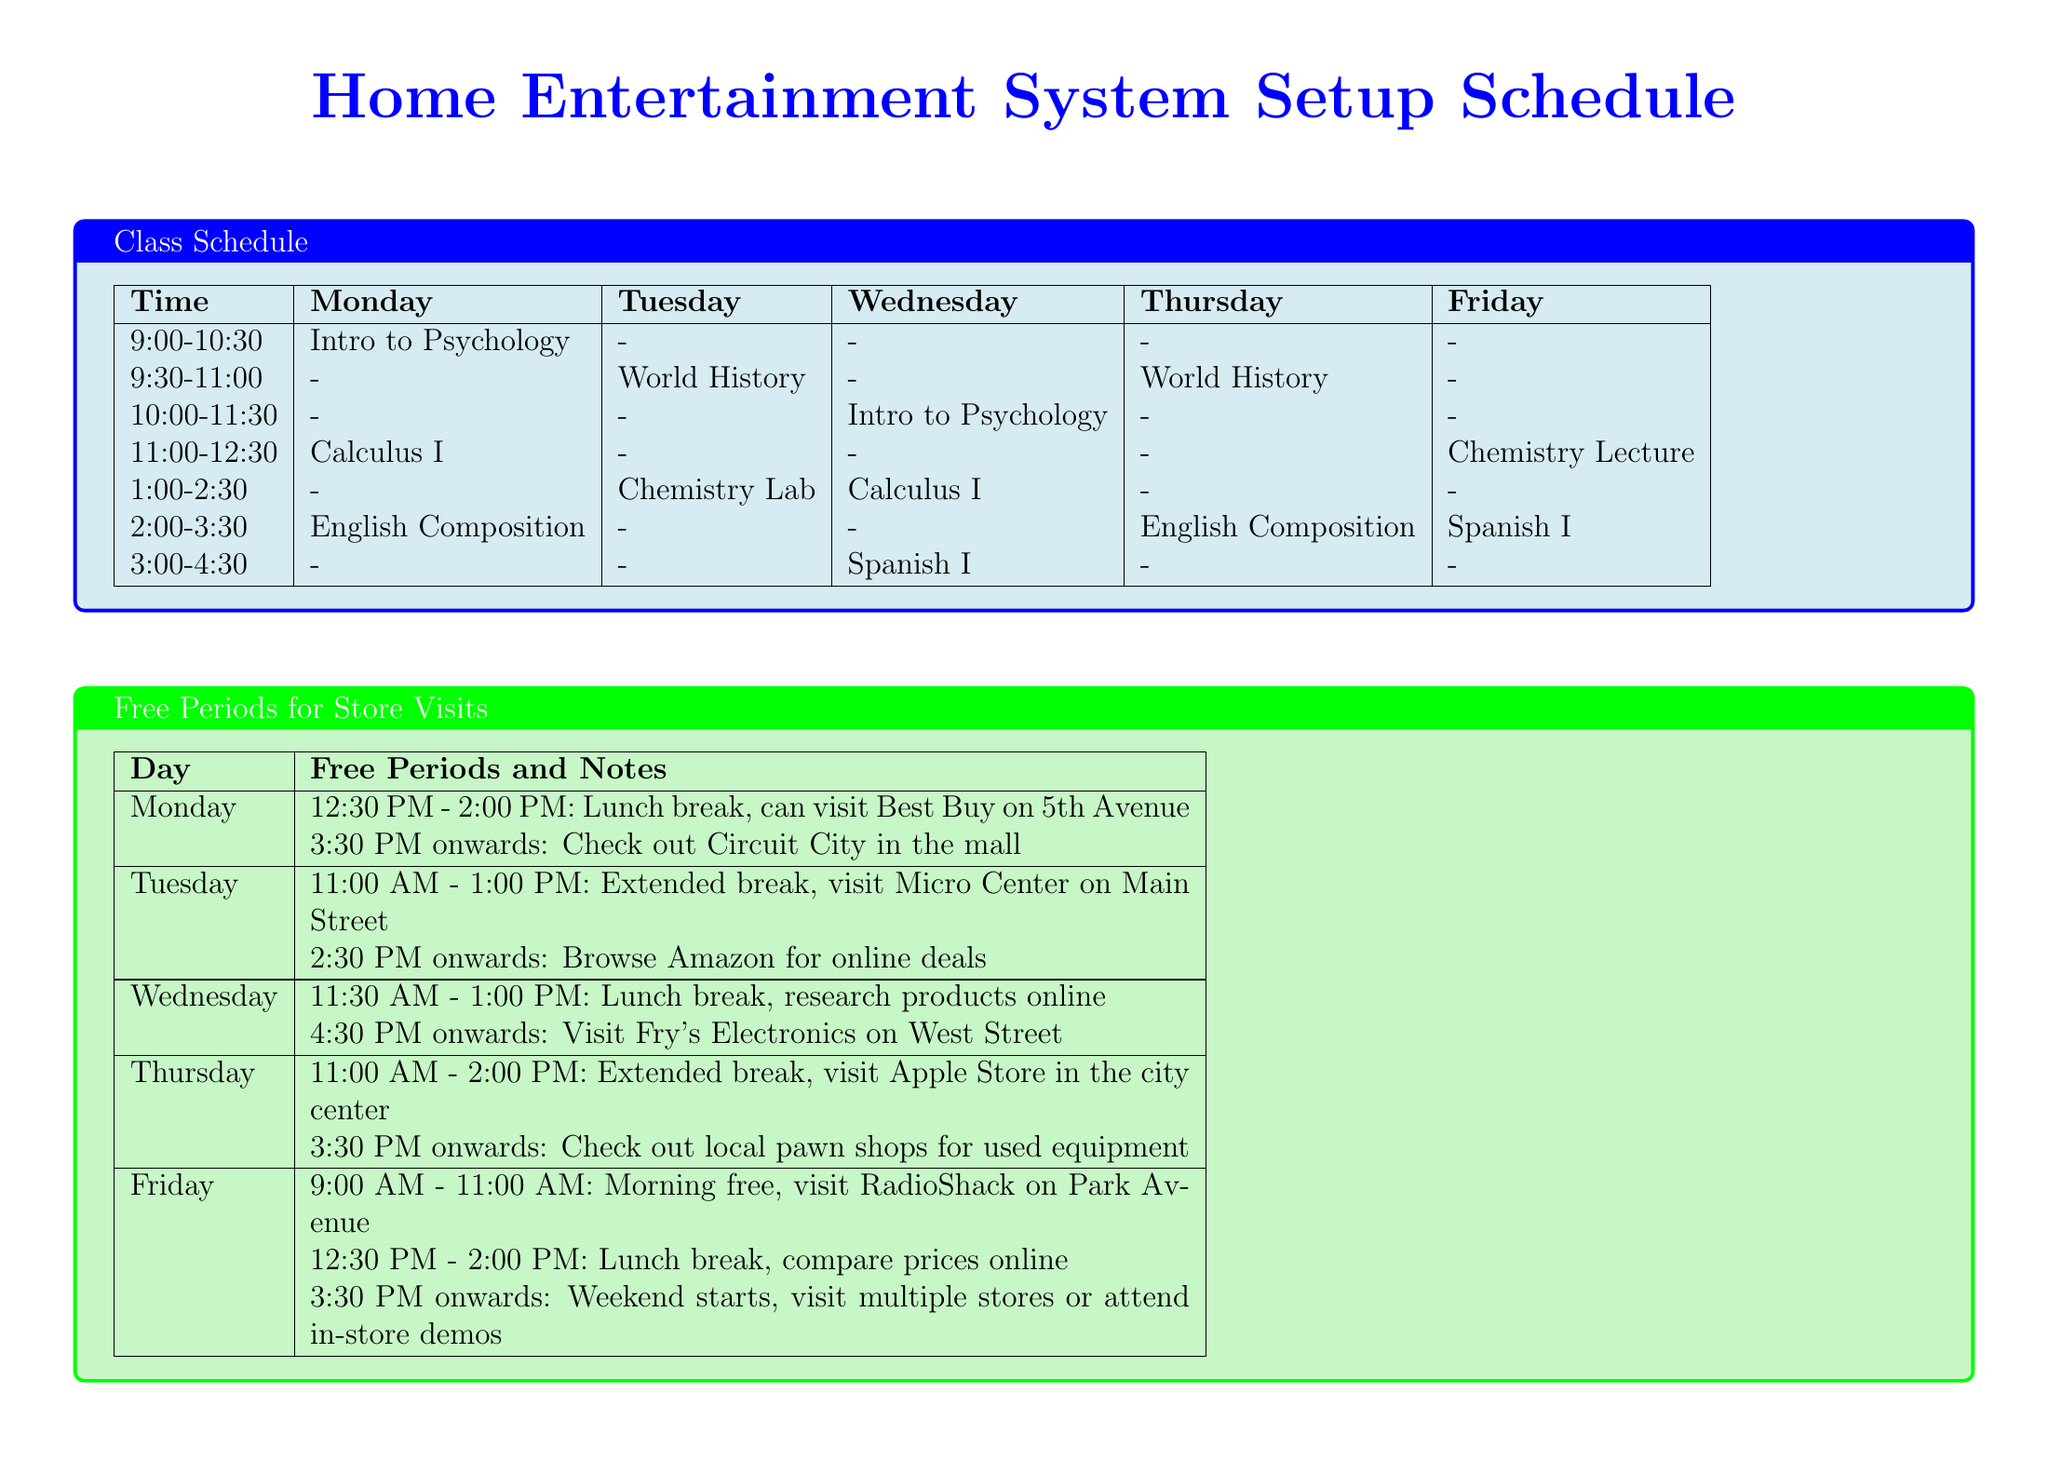What class is scheduled on Monday at 9:00 AM? The class scheduled at 9:00 AM on Monday is listed in the class schedule under that time slot.
Answer: Introduction to Psychology What time is the lunch break on Tuesday? The document specifies the free periods for each day, including lunch breaks, and for Tuesday, it lists the timing.
Answer: 11:00 AM - 1:00 PM Which store can be visited after the free period on Thursday? By checking the notes on free periods for Thursday, we can determine which store is suggested to visit after the noted times.
Answer: Apple Store in the city center How many classes are scheduled on Wednesday? The class schedule lists the classes for each day, and we can count the number of classes scheduled on Wednesday.
Answer: 3 What is the address of Micro Center? The nearby electronics stores section provides the addresses for each store, including Micro Center.
Answer: 456 Main Street Which brand is recommended for soundbars? The home entertainment components section suggests specific brands to consider for different items, including soundbars.
Answer: Sonos, Bose, Vizio, JBL What free period activity is suggested for Friday morning? The document mentions the free period for Friday morning, explaining the recommended activity during that time.
Answer: Visit RadioShack on Park Avenue What class immediately follows Calculus I on Monday? By analyzing the class schedule on Monday, we can see which class comes after Calculus I.
Answer: English Composition 